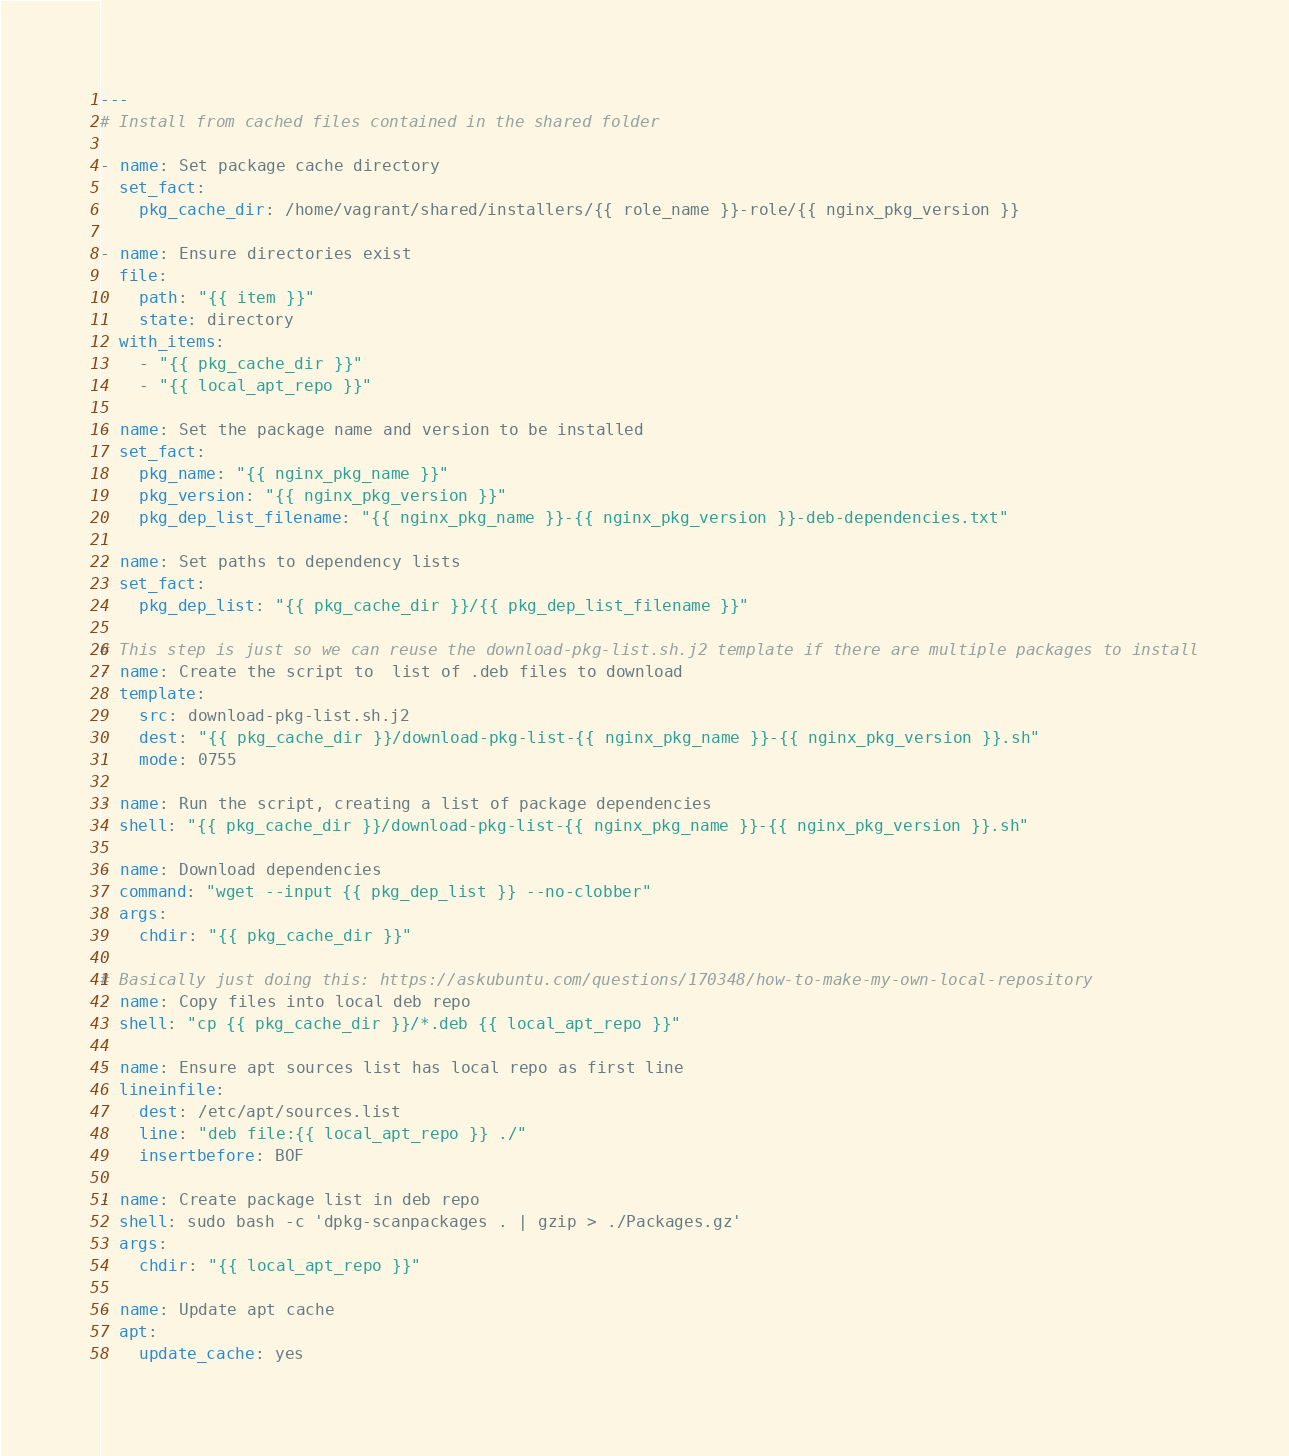Convert code to text. <code><loc_0><loc_0><loc_500><loc_500><_YAML_>---
# Install from cached files contained in the shared folder

- name: Set package cache directory
  set_fact:
    pkg_cache_dir: /home/vagrant/shared/installers/{{ role_name }}-role/{{ nginx_pkg_version }}

- name: Ensure directories exist
  file:
    path: "{{ item }}"
    state: directory
  with_items:
    - "{{ pkg_cache_dir }}"
    - "{{ local_apt_repo }}"

- name: Set the package name and version to be installed
  set_fact:
    pkg_name: "{{ nginx_pkg_name }}"
    pkg_version: "{{ nginx_pkg_version }}"
    pkg_dep_list_filename: "{{ nginx_pkg_name }}-{{ nginx_pkg_version }}-deb-dependencies.txt"

- name: Set paths to dependency lists
  set_fact:
    pkg_dep_list: "{{ pkg_cache_dir }}/{{ pkg_dep_list_filename }}"

# This step is just so we can reuse the download-pkg-list.sh.j2 template if there are multiple packages to install
- name: Create the script to  list of .deb files to download
  template:
    src: download-pkg-list.sh.j2
    dest: "{{ pkg_cache_dir }}/download-pkg-list-{{ nginx_pkg_name }}-{{ nginx_pkg_version }}.sh"
    mode: 0755

- name: Run the script, creating a list of package dependencies
  shell: "{{ pkg_cache_dir }}/download-pkg-list-{{ nginx_pkg_name }}-{{ nginx_pkg_version }}.sh"

- name: Download dependencies
  command: "wget --input {{ pkg_dep_list }} --no-clobber"
  args:
    chdir: "{{ pkg_cache_dir }}"

# Basically just doing this: https://askubuntu.com/questions/170348/how-to-make-my-own-local-repository
- name: Copy files into local deb repo
  shell: "cp {{ pkg_cache_dir }}/*.deb {{ local_apt_repo }}"

- name: Ensure apt sources list has local repo as first line
  lineinfile:
    dest: /etc/apt/sources.list
    line: "deb file:{{ local_apt_repo }} ./"
    insertbefore: BOF

- name: Create package list in deb repo
  shell: sudo bash -c 'dpkg-scanpackages . | gzip > ./Packages.gz'
  args:
    chdir: "{{ local_apt_repo }}"

- name: Update apt cache
  apt:
    update_cache: yes</code> 